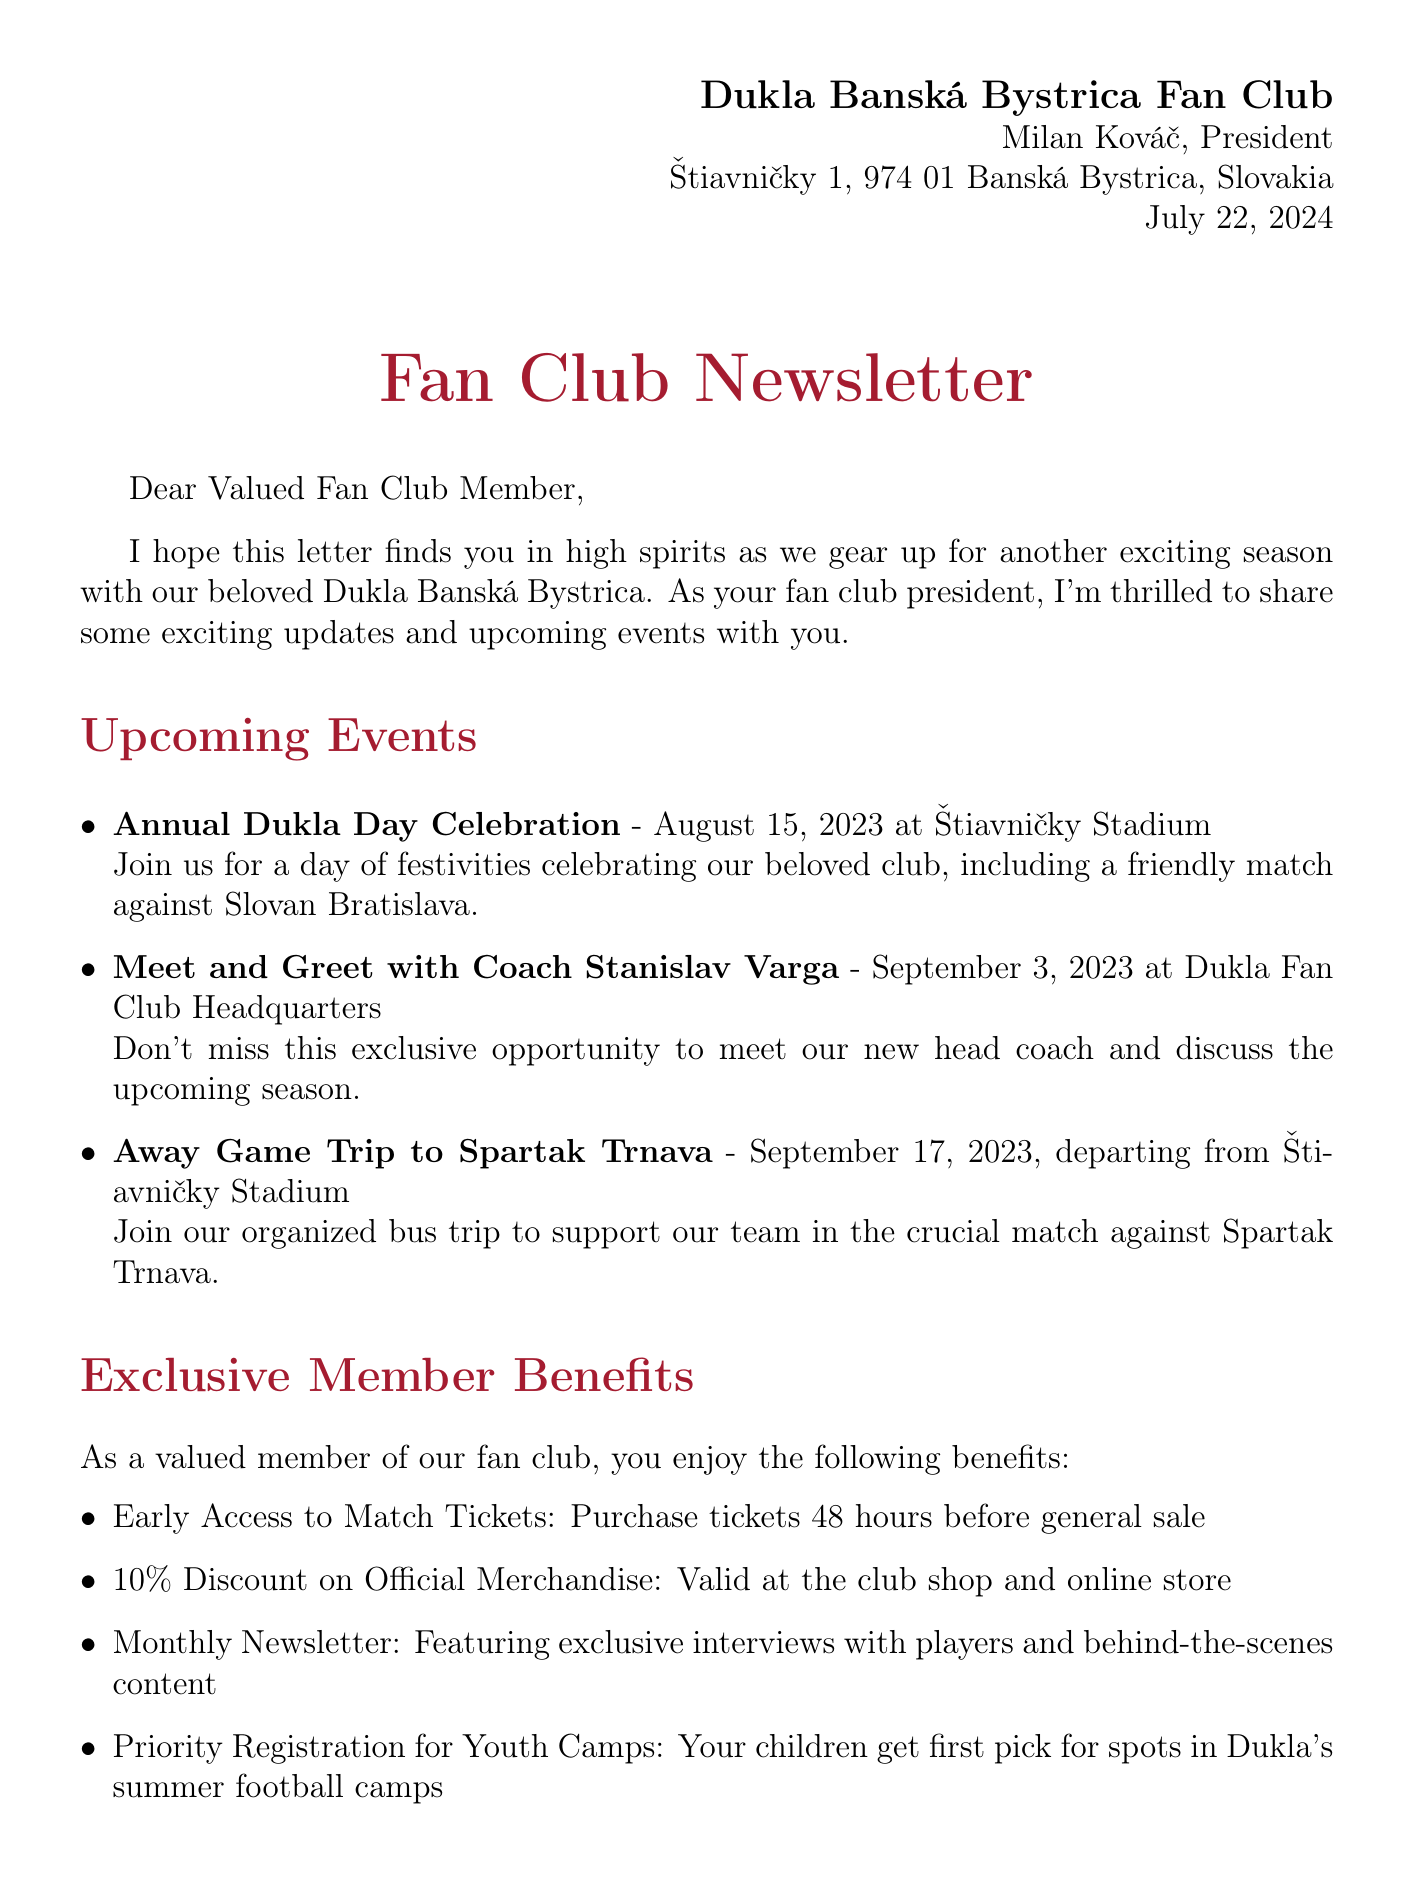What is the name of the fan club president? The letter introduces Milan Kováč as the president of the Dukla Banská Bystrica Fan Club.
Answer: Milan Kováč What is the location of the Annual Dukla Day Celebration? The letter specifies that the Annual Dukla Day Celebration will take place at Štiavničky Stadium.
Answer: Štiavničky Stadium When is the membership renewal due date? The document states that the membership renewal is due by October 31, 2023.
Answer: October 31, 2023 What discount do members receive on official merchandise? The letter mentions that members can enjoy a 10% discount on official merchandise.
Answer: 10% Which event provides an opportunity to meet the new head coach? The letter indicates that the meet and greet with Coach Stanislav Varga will allow members to meet the new head coach.
Answer: Meet and Greet with Coach Stanislav Varga What are the recent achievements mentioned in the letter? The document highlights achievements including qualification for the 2023-24 Slovak Cup and youth academy success.
Answer: Qualification for the 2023-24 Slovak Cup, Youth Academy Success When is the deadline for the early bird discount on membership renewal? The letter states that the early bird discount is available if renewed before September 15, 2023.
Answer: September 15, 2023 What is the motto of the Dukla Banská Bystrica Fan Club? The letter concludes with the club's motto, expressing pride in their history and excitement for the future.
Answer: Hrdí na našu históriu, nadšení pre našu budúcnosť! 